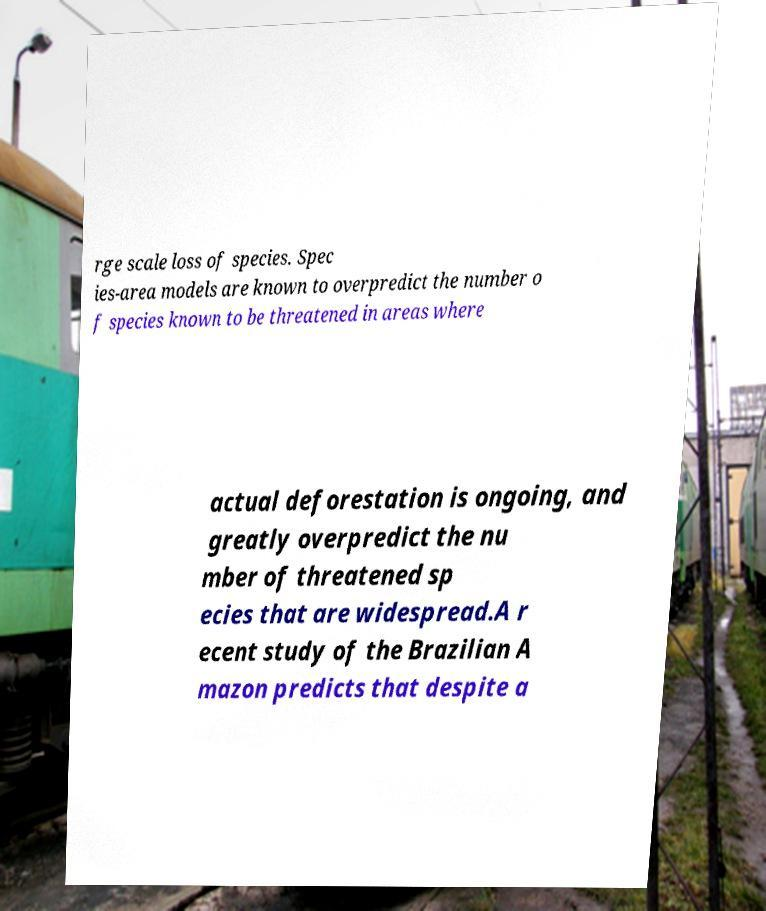Can you accurately transcribe the text from the provided image for me? rge scale loss of species. Spec ies-area models are known to overpredict the number o f species known to be threatened in areas where actual deforestation is ongoing, and greatly overpredict the nu mber of threatened sp ecies that are widespread.A r ecent study of the Brazilian A mazon predicts that despite a 